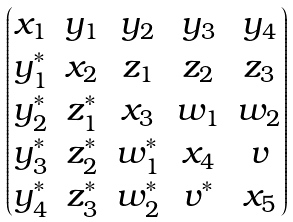Convert formula to latex. <formula><loc_0><loc_0><loc_500><loc_500>\begin{pmatrix} x _ { 1 } & y _ { 1 } & y _ { 2 } & y _ { 3 } & y _ { 4 } \\ y _ { 1 } ^ { * } & x _ { 2 } & z _ { 1 } & z _ { 2 } & z _ { 3 } \\ y _ { 2 } ^ { * } & z _ { 1 } ^ { * } & x _ { 3 } & w _ { 1 } & w _ { 2 } \\ y _ { 3 } ^ { * } & z _ { 2 } ^ { * } & w _ { 1 } ^ { * } & x _ { 4 } & v \\ y _ { 4 } ^ { * } & z _ { 3 } ^ { * } & w _ { 2 } ^ { * } & v ^ { * } & x _ { 5 } \end{pmatrix}</formula> 